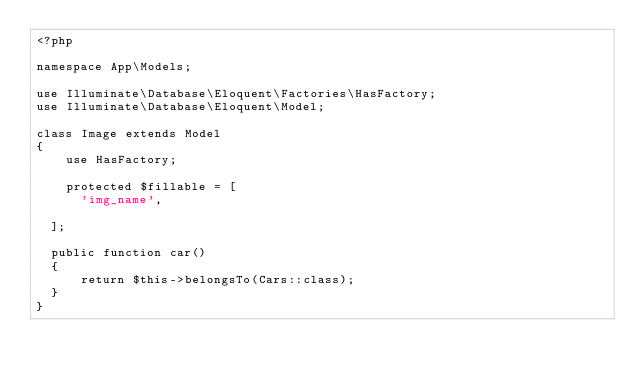Convert code to text. <code><loc_0><loc_0><loc_500><loc_500><_PHP_><?php

namespace App\Models;

use Illuminate\Database\Eloquent\Factories\HasFactory;
use Illuminate\Database\Eloquent\Model;

class Image extends Model
{
    use HasFactory;

    protected $fillable = [
      'img_name',
     
  ];
  
  public function car()
  {
      return $this->belongsTo(Cars::class);
  }
}
</code> 